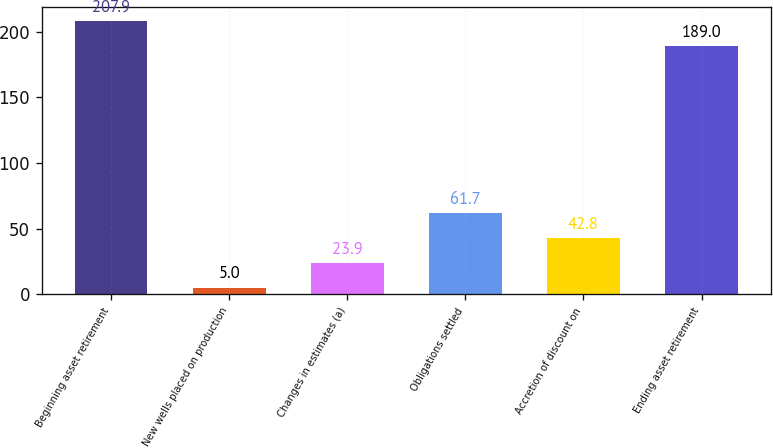Convert chart. <chart><loc_0><loc_0><loc_500><loc_500><bar_chart><fcel>Beginning asset retirement<fcel>New wells placed on production<fcel>Changes in estimates (a)<fcel>Obligations settled<fcel>Accretion of discount on<fcel>Ending asset retirement<nl><fcel>207.9<fcel>5<fcel>23.9<fcel>61.7<fcel>42.8<fcel>189<nl></chart> 